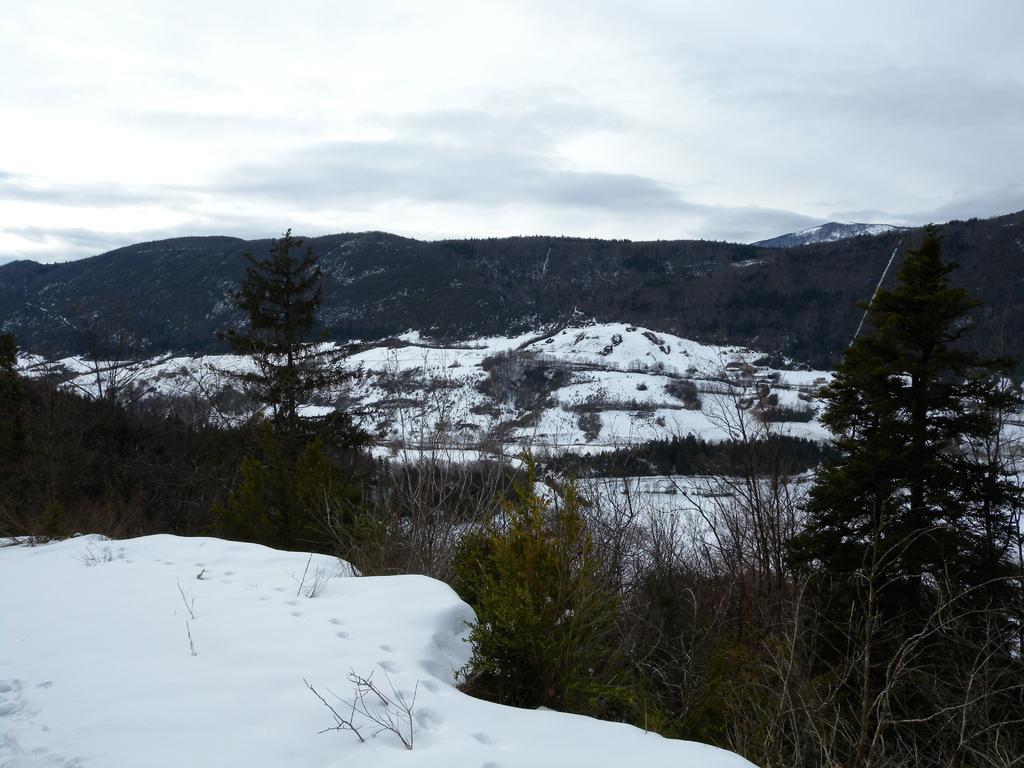What is present at the bottom of the picture? There is ice and trees at the bottom of the picture. What can be seen in the background of the picture? There are hills, trees, and ice in the background of the picture. What is visible at the top of the picture? The sky is visible at the top of the picture. How many horses are visible in the bedroom in the image? There are no horses or bedrooms present in the image. What type of appliance can be seen in the ice in the background? There is no appliance visible in the ice in the background of the image. 